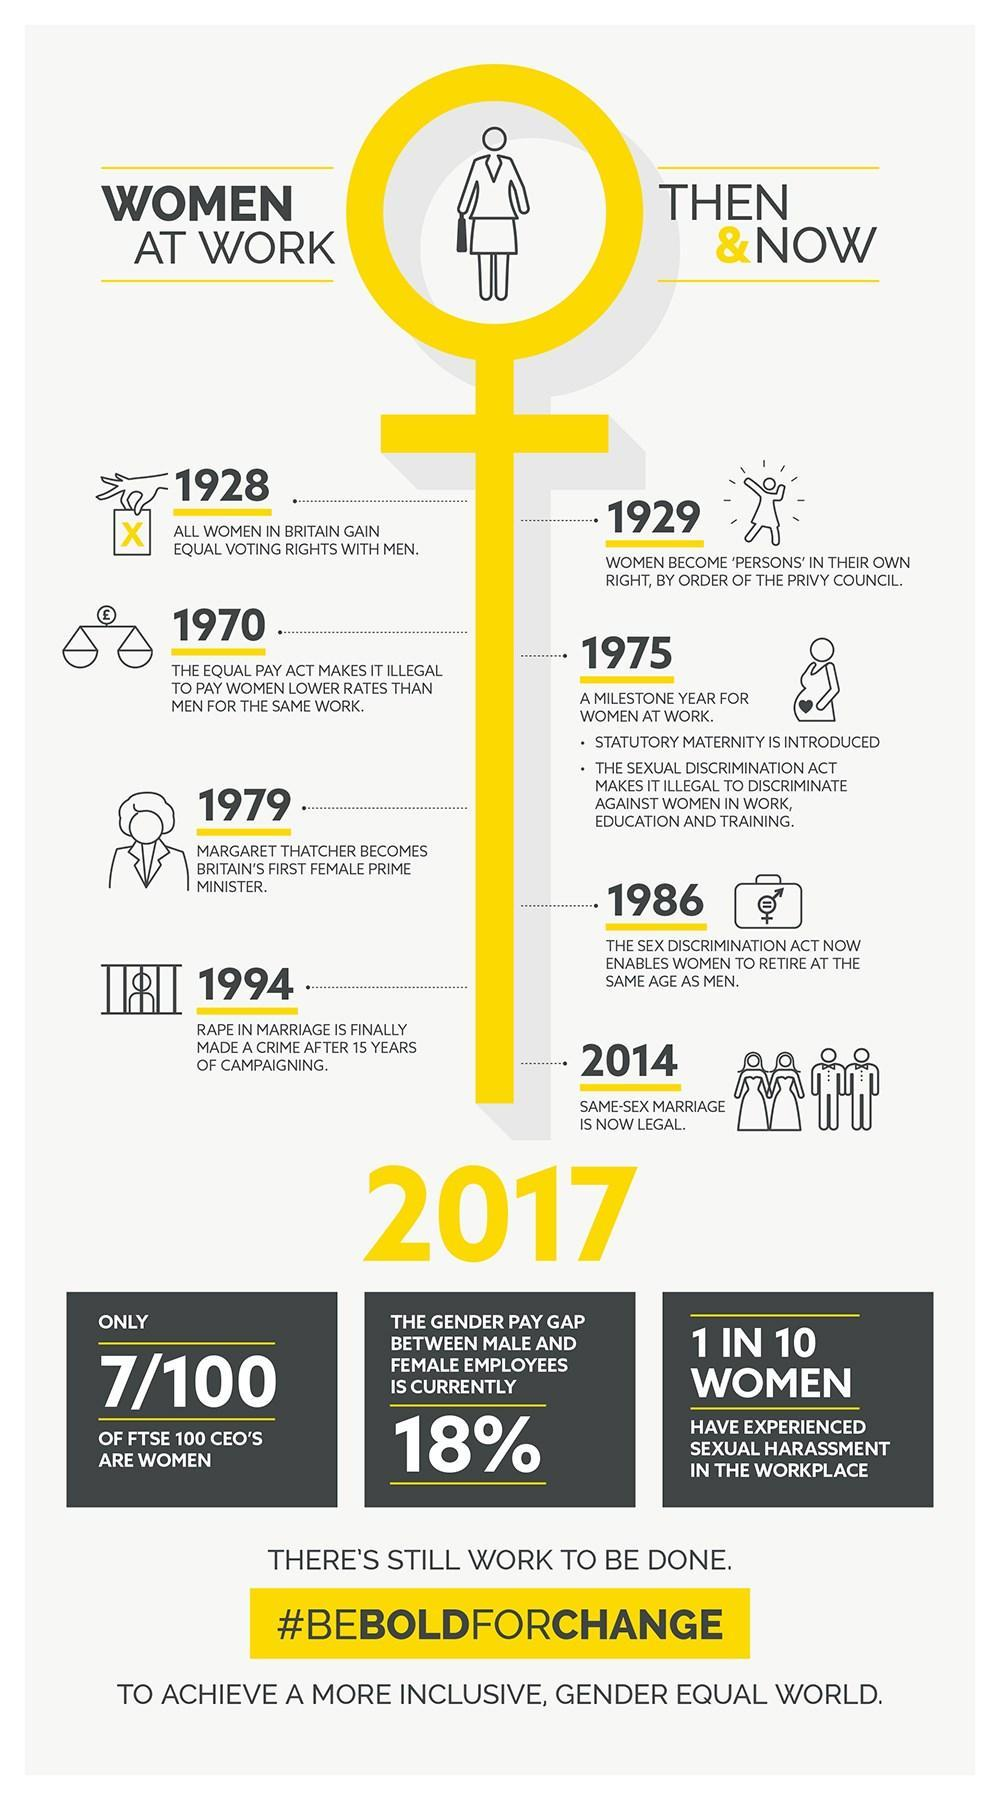In which year was rape in marriage finally made a crime?
Answer the question with a short phrase. 1994 Which year was considered as the milestone year for women at work? 1975 Until 1970 who were paid more, women or men? Men In which year did the "campaigning"  against 'rape in marriage' begin? 1979 How many FTSE 100 CEOs are women? 7 In which year did women in Britain get equal voting rights? 1928 In which year was 'equal pay for women' legalised? 1970 In which year did Britain have its first female prime minister? 1979 Out of every 10 women how many have experienced sexual harassment in workplace? 1 What is the gender pay gap between male and female employees? 18% What came first, equal voting rights for women or equal payment for women? Equal voting rights for women In which year did women become 'persons' in their own right? 1929 Until 1928, who had the exclusive right to vote, women or men? Men When was statutory maternity introduced? 1975 When was same sex marriage made legal? 2014 In which year did the Sexual Discrimination Act make it illegal to discriminate against women in work, education and training? 1975 From which year onwards, where women allowed to retire at the same age as men? 1986 